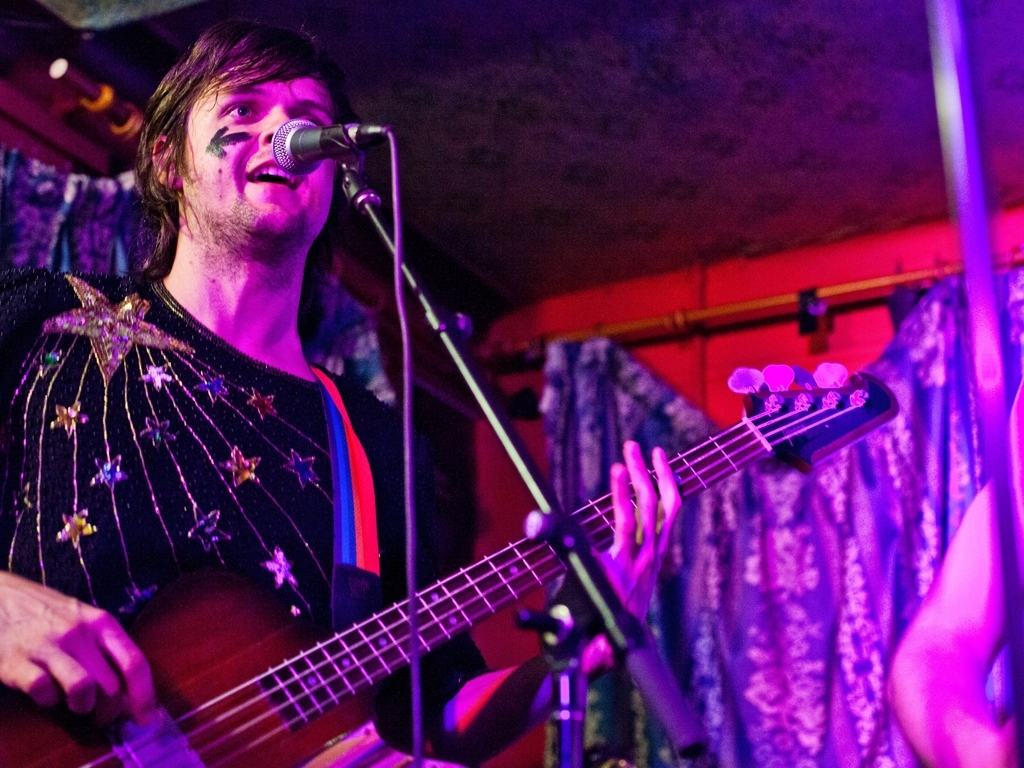Can you describe the atmosphere of the location where this individual is performing? The image captures a vibrant and intimate atmosphere that’s often found in live music venues. The warm stage lighting and the close proximity of the audience suggest a personal and engaging experience for both the performer and the listeners. 